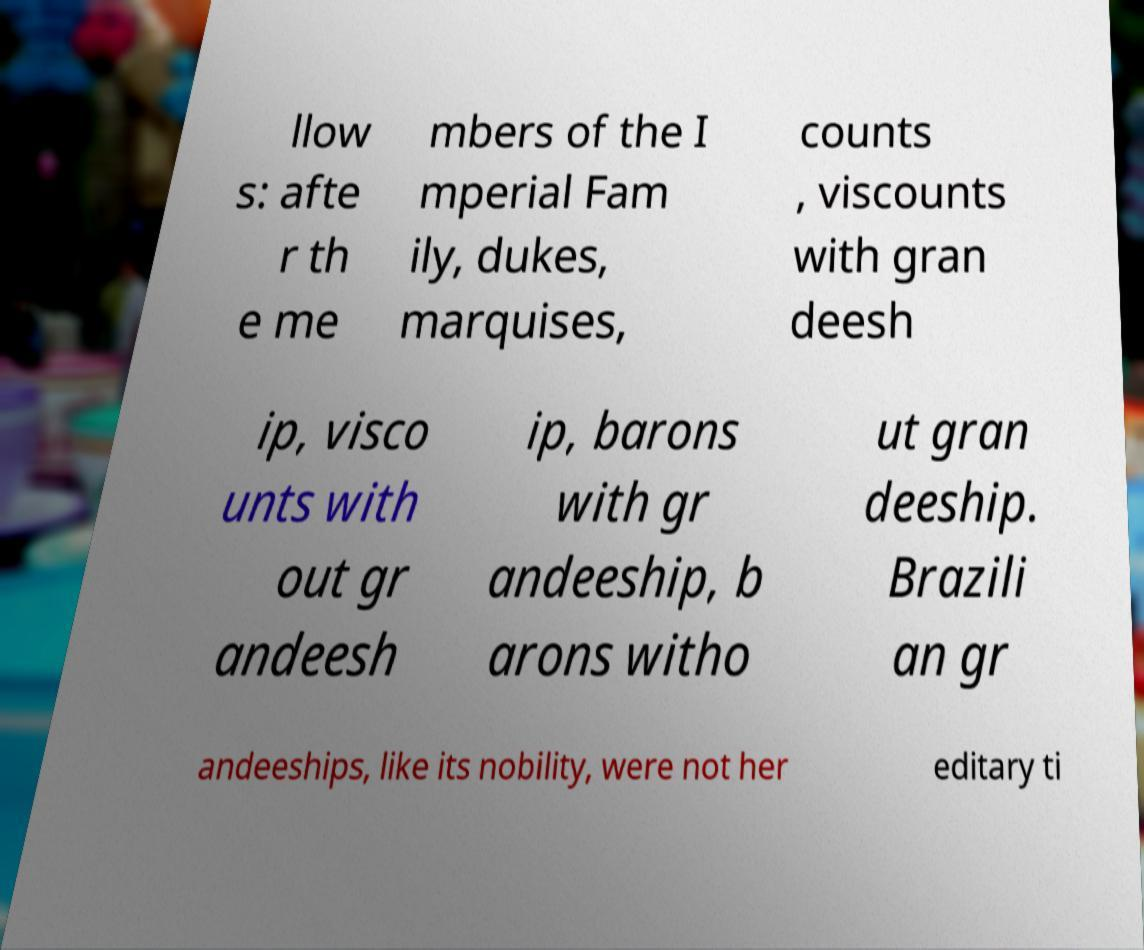Can you accurately transcribe the text from the provided image for me? llow s: afte r th e me mbers of the I mperial Fam ily, dukes, marquises, counts , viscounts with gran deesh ip, visco unts with out gr andeesh ip, barons with gr andeeship, b arons witho ut gran deeship. Brazili an gr andeeships, like its nobility, were not her editary ti 